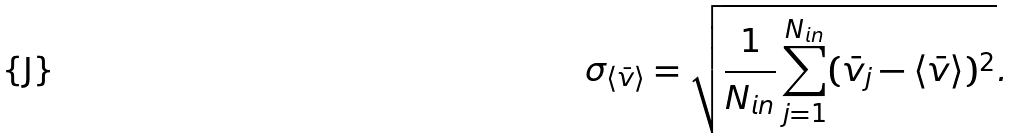<formula> <loc_0><loc_0><loc_500><loc_500>\sigma _ { \langle \bar { v } \rangle } = \sqrt { \frac { 1 } { N _ { i n } } \sum _ { j = 1 } ^ { N _ { i n } } ( \bar { v } _ { j } - \langle \bar { v } \rangle ) ^ { 2 } } .</formula> 